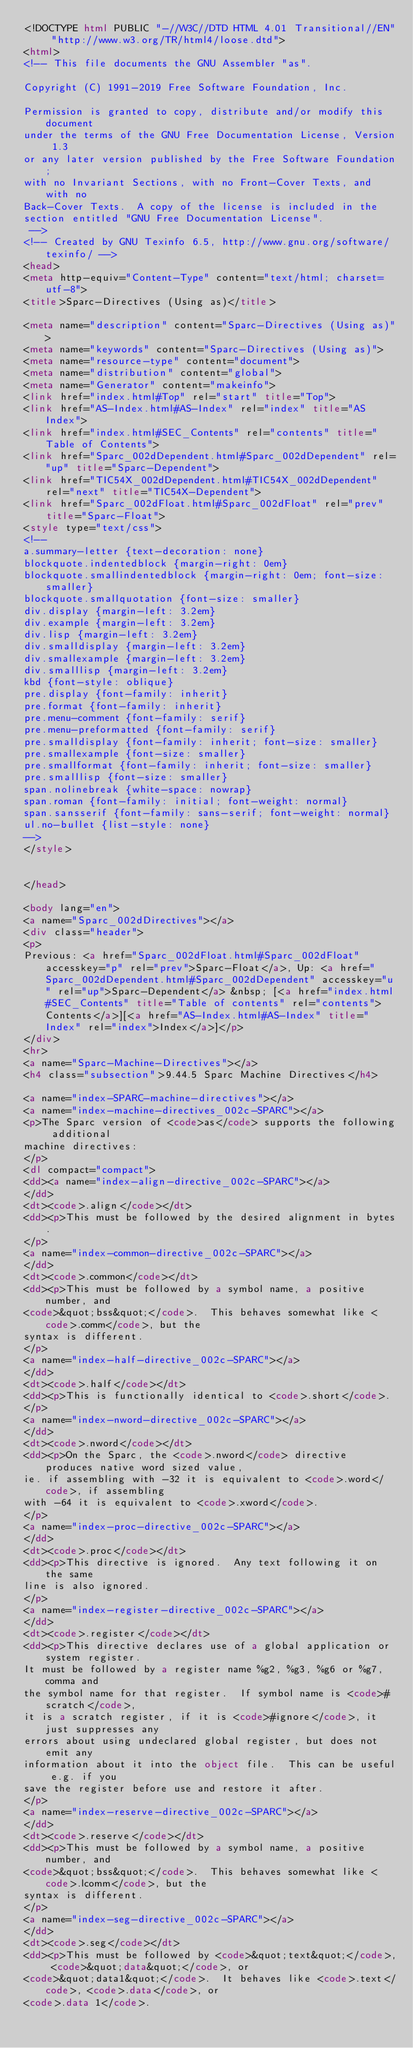<code> <loc_0><loc_0><loc_500><loc_500><_HTML_><!DOCTYPE html PUBLIC "-//W3C//DTD HTML 4.01 Transitional//EN" "http://www.w3.org/TR/html4/loose.dtd">
<html>
<!-- This file documents the GNU Assembler "as".

Copyright (C) 1991-2019 Free Software Foundation, Inc.

Permission is granted to copy, distribute and/or modify this document
under the terms of the GNU Free Documentation License, Version 1.3
or any later version published by the Free Software Foundation;
with no Invariant Sections, with no Front-Cover Texts, and with no
Back-Cover Texts.  A copy of the license is included in the
section entitled "GNU Free Documentation License".
 -->
<!-- Created by GNU Texinfo 6.5, http://www.gnu.org/software/texinfo/ -->
<head>
<meta http-equiv="Content-Type" content="text/html; charset=utf-8">
<title>Sparc-Directives (Using as)</title>

<meta name="description" content="Sparc-Directives (Using as)">
<meta name="keywords" content="Sparc-Directives (Using as)">
<meta name="resource-type" content="document">
<meta name="distribution" content="global">
<meta name="Generator" content="makeinfo">
<link href="index.html#Top" rel="start" title="Top">
<link href="AS-Index.html#AS-Index" rel="index" title="AS Index">
<link href="index.html#SEC_Contents" rel="contents" title="Table of Contents">
<link href="Sparc_002dDependent.html#Sparc_002dDependent" rel="up" title="Sparc-Dependent">
<link href="TIC54X_002dDependent.html#TIC54X_002dDependent" rel="next" title="TIC54X-Dependent">
<link href="Sparc_002dFloat.html#Sparc_002dFloat" rel="prev" title="Sparc-Float">
<style type="text/css">
<!--
a.summary-letter {text-decoration: none}
blockquote.indentedblock {margin-right: 0em}
blockquote.smallindentedblock {margin-right: 0em; font-size: smaller}
blockquote.smallquotation {font-size: smaller}
div.display {margin-left: 3.2em}
div.example {margin-left: 3.2em}
div.lisp {margin-left: 3.2em}
div.smalldisplay {margin-left: 3.2em}
div.smallexample {margin-left: 3.2em}
div.smalllisp {margin-left: 3.2em}
kbd {font-style: oblique}
pre.display {font-family: inherit}
pre.format {font-family: inherit}
pre.menu-comment {font-family: serif}
pre.menu-preformatted {font-family: serif}
pre.smalldisplay {font-family: inherit; font-size: smaller}
pre.smallexample {font-size: smaller}
pre.smallformat {font-family: inherit; font-size: smaller}
pre.smalllisp {font-size: smaller}
span.nolinebreak {white-space: nowrap}
span.roman {font-family: initial; font-weight: normal}
span.sansserif {font-family: sans-serif; font-weight: normal}
ul.no-bullet {list-style: none}
-->
</style>


</head>

<body lang="en">
<a name="Sparc_002dDirectives"></a>
<div class="header">
<p>
Previous: <a href="Sparc_002dFloat.html#Sparc_002dFloat" accesskey="p" rel="prev">Sparc-Float</a>, Up: <a href="Sparc_002dDependent.html#Sparc_002dDependent" accesskey="u" rel="up">Sparc-Dependent</a> &nbsp; [<a href="index.html#SEC_Contents" title="Table of contents" rel="contents">Contents</a>][<a href="AS-Index.html#AS-Index" title="Index" rel="index">Index</a>]</p>
</div>
<hr>
<a name="Sparc-Machine-Directives"></a>
<h4 class="subsection">9.44.5 Sparc Machine Directives</h4>

<a name="index-SPARC-machine-directives"></a>
<a name="index-machine-directives_002c-SPARC"></a>
<p>The Sparc version of <code>as</code> supports the following additional
machine directives:
</p>
<dl compact="compact">
<dd><a name="index-align-directive_002c-SPARC"></a>
</dd>
<dt><code>.align</code></dt>
<dd><p>This must be followed by the desired alignment in bytes.
</p>
<a name="index-common-directive_002c-SPARC"></a>
</dd>
<dt><code>.common</code></dt>
<dd><p>This must be followed by a symbol name, a positive number, and
<code>&quot;bss&quot;</code>.  This behaves somewhat like <code>.comm</code>, but the
syntax is different.
</p>
<a name="index-half-directive_002c-SPARC"></a>
</dd>
<dt><code>.half</code></dt>
<dd><p>This is functionally identical to <code>.short</code>.
</p>
<a name="index-nword-directive_002c-SPARC"></a>
</dd>
<dt><code>.nword</code></dt>
<dd><p>On the Sparc, the <code>.nword</code> directive produces native word sized value,
ie. if assembling with -32 it is equivalent to <code>.word</code>, if assembling
with -64 it is equivalent to <code>.xword</code>.
</p>
<a name="index-proc-directive_002c-SPARC"></a>
</dd>
<dt><code>.proc</code></dt>
<dd><p>This directive is ignored.  Any text following it on the same
line is also ignored.
</p>
<a name="index-register-directive_002c-SPARC"></a>
</dd>
<dt><code>.register</code></dt>
<dd><p>This directive declares use of a global application or system register.
It must be followed by a register name %g2, %g3, %g6 or %g7, comma and
the symbol name for that register.  If symbol name is <code>#scratch</code>,
it is a scratch register, if it is <code>#ignore</code>, it just suppresses any
errors about using undeclared global register, but does not emit any
information about it into the object file.  This can be useful e.g. if you
save the register before use and restore it after.
</p>
<a name="index-reserve-directive_002c-SPARC"></a>
</dd>
<dt><code>.reserve</code></dt>
<dd><p>This must be followed by a symbol name, a positive number, and
<code>&quot;bss&quot;</code>.  This behaves somewhat like <code>.lcomm</code>, but the
syntax is different.
</p>
<a name="index-seg-directive_002c-SPARC"></a>
</dd>
<dt><code>.seg</code></dt>
<dd><p>This must be followed by <code>&quot;text&quot;</code>, <code>&quot;data&quot;</code>, or
<code>&quot;data1&quot;</code>.  It behaves like <code>.text</code>, <code>.data</code>, or
<code>.data 1</code>.</code> 